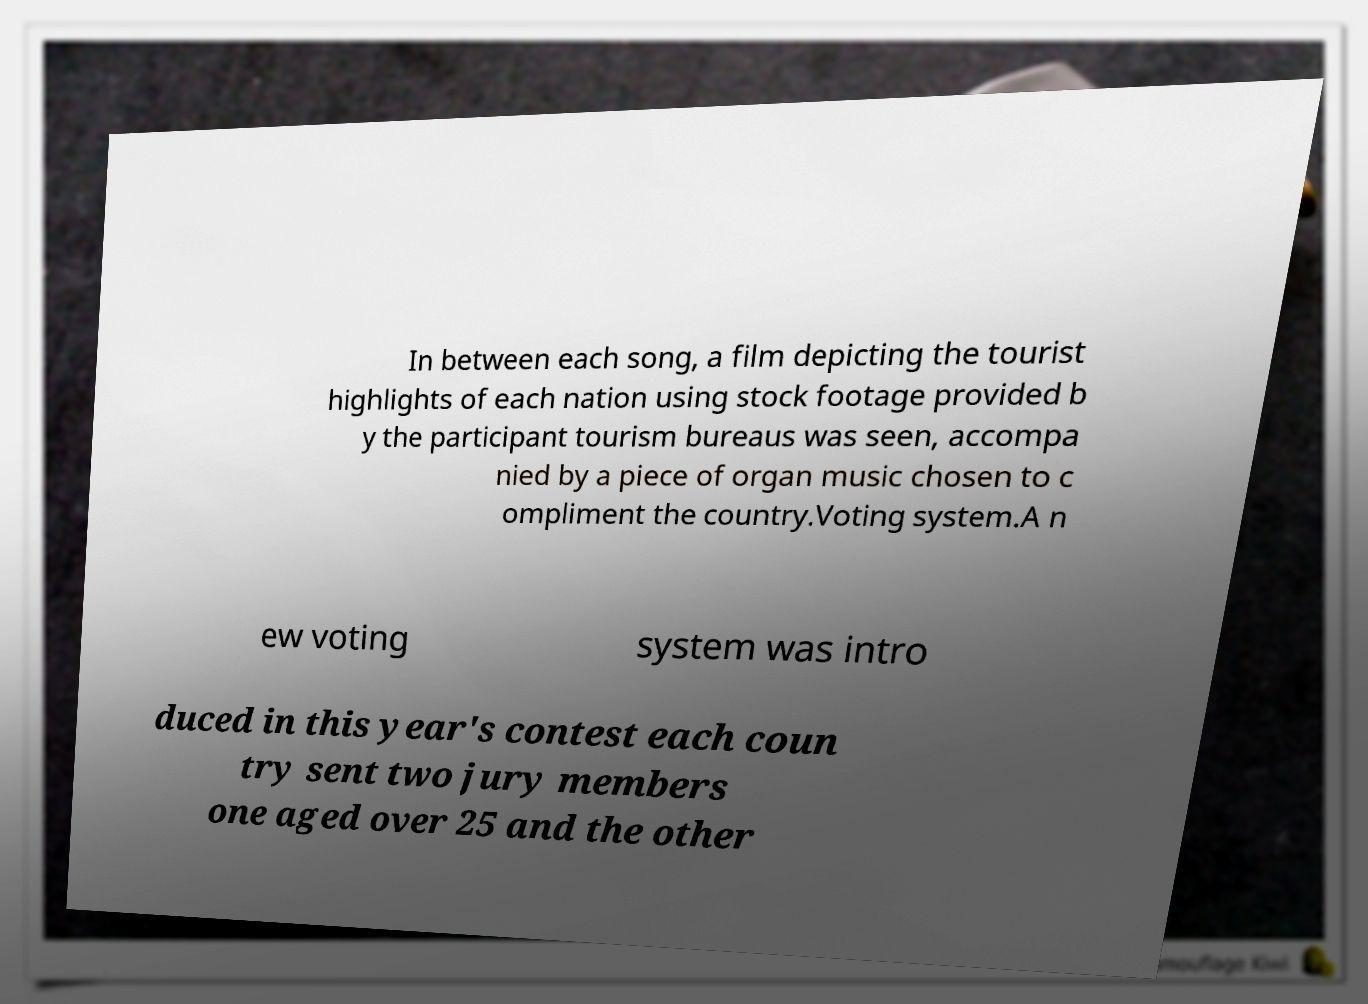Please identify and transcribe the text found in this image. In between each song, a film depicting the tourist highlights of each nation using stock footage provided b y the participant tourism bureaus was seen, accompa nied by a piece of organ music chosen to c ompliment the country.Voting system.A n ew voting system was intro duced in this year's contest each coun try sent two jury members one aged over 25 and the other 